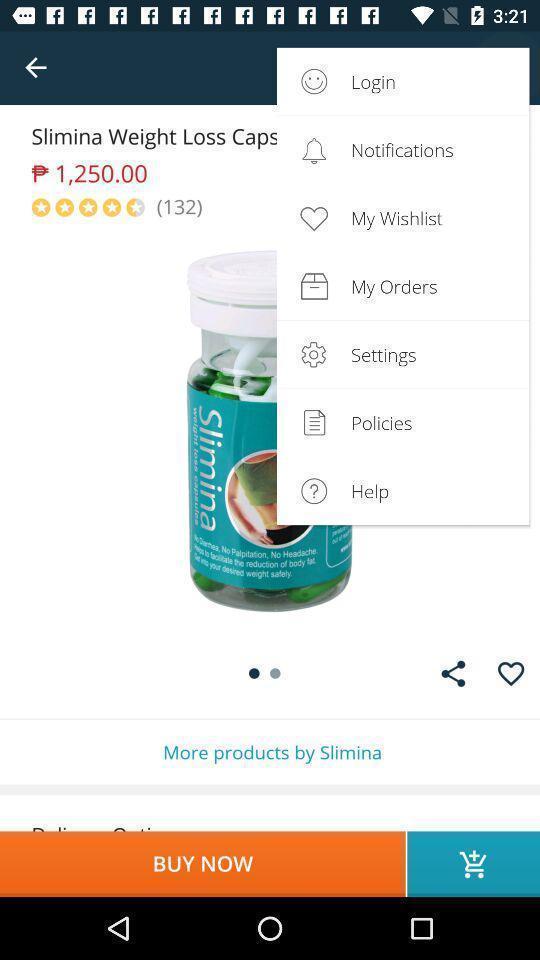What is the overall content of this screenshot? Pop up showing multiple options on shopping app. 